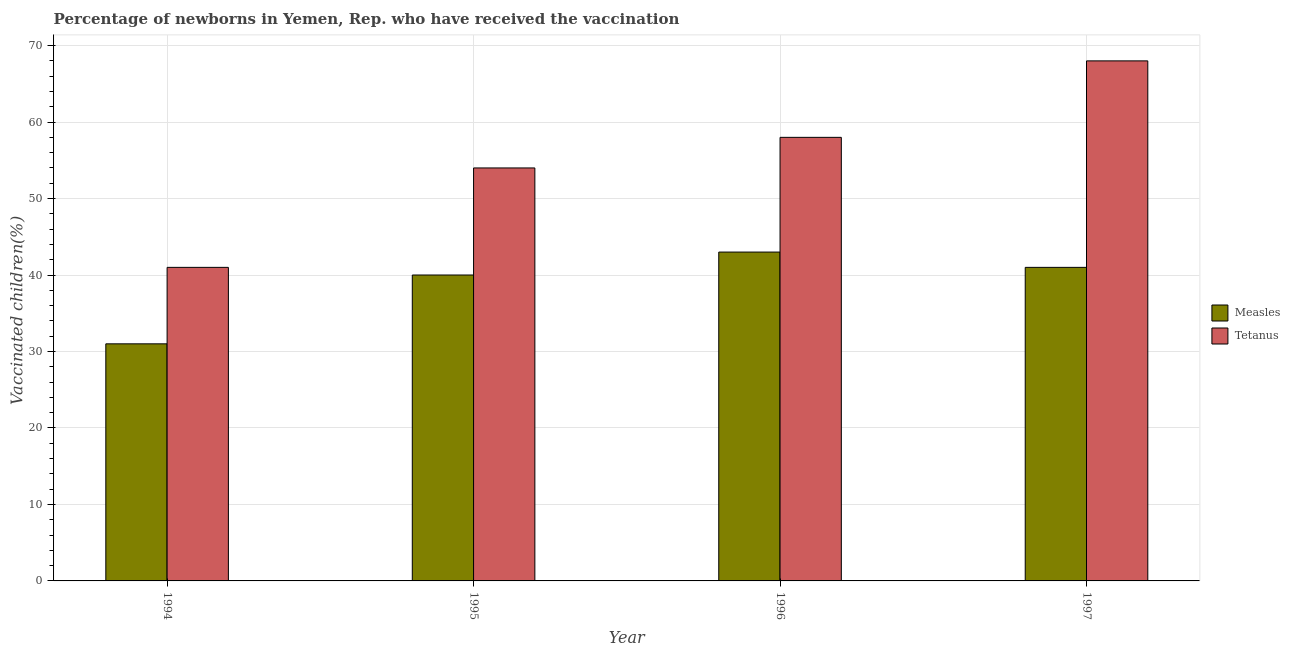How many different coloured bars are there?
Provide a succinct answer. 2. How many groups of bars are there?
Offer a very short reply. 4. Are the number of bars per tick equal to the number of legend labels?
Give a very brief answer. Yes. Are the number of bars on each tick of the X-axis equal?
Make the answer very short. Yes. What is the percentage of newborns who received vaccination for tetanus in 1995?
Your answer should be very brief. 54. Across all years, what is the maximum percentage of newborns who received vaccination for measles?
Provide a short and direct response. 43. Across all years, what is the minimum percentage of newborns who received vaccination for measles?
Your answer should be very brief. 31. What is the total percentage of newborns who received vaccination for measles in the graph?
Offer a very short reply. 155. What is the difference between the percentage of newborns who received vaccination for measles in 1994 and that in 1997?
Keep it short and to the point. -10. What is the difference between the percentage of newborns who received vaccination for measles in 1997 and the percentage of newborns who received vaccination for tetanus in 1996?
Ensure brevity in your answer.  -2. What is the average percentage of newborns who received vaccination for tetanus per year?
Your answer should be very brief. 55.25. In the year 1995, what is the difference between the percentage of newborns who received vaccination for tetanus and percentage of newborns who received vaccination for measles?
Your answer should be very brief. 0. In how many years, is the percentage of newborns who received vaccination for tetanus greater than 52 %?
Provide a succinct answer. 3. What is the ratio of the percentage of newborns who received vaccination for tetanus in 1995 to that in 1996?
Provide a short and direct response. 0.93. Is the percentage of newborns who received vaccination for tetanus in 1995 less than that in 1997?
Make the answer very short. Yes. What is the difference between the highest and the lowest percentage of newborns who received vaccination for tetanus?
Provide a short and direct response. 27. In how many years, is the percentage of newborns who received vaccination for measles greater than the average percentage of newborns who received vaccination for measles taken over all years?
Provide a succinct answer. 3. Is the sum of the percentage of newborns who received vaccination for tetanus in 1994 and 1995 greater than the maximum percentage of newborns who received vaccination for measles across all years?
Give a very brief answer. Yes. What does the 1st bar from the left in 1994 represents?
Your response must be concise. Measles. What does the 1st bar from the right in 1996 represents?
Your answer should be compact. Tetanus. Are all the bars in the graph horizontal?
Make the answer very short. No. How many years are there in the graph?
Provide a succinct answer. 4. Are the values on the major ticks of Y-axis written in scientific E-notation?
Make the answer very short. No. Does the graph contain grids?
Offer a terse response. Yes. How are the legend labels stacked?
Offer a terse response. Vertical. What is the title of the graph?
Your response must be concise. Percentage of newborns in Yemen, Rep. who have received the vaccination. What is the label or title of the Y-axis?
Keep it short and to the point. Vaccinated children(%)
. What is the Vaccinated children(%)
 in Measles in 1994?
Provide a short and direct response. 31. What is the Vaccinated children(%)
 of Tetanus in 1996?
Provide a short and direct response. 58. What is the Vaccinated children(%)
 of Tetanus in 1997?
Keep it short and to the point. 68. What is the total Vaccinated children(%)
 in Measles in the graph?
Provide a short and direct response. 155. What is the total Vaccinated children(%)
 in Tetanus in the graph?
Provide a succinct answer. 221. What is the difference between the Vaccinated children(%)
 in Tetanus in 1994 and that in 1995?
Give a very brief answer. -13. What is the difference between the Vaccinated children(%)
 in Measles in 1994 and that in 1996?
Provide a succinct answer. -12. What is the difference between the Vaccinated children(%)
 of Tetanus in 1994 and that in 1997?
Provide a succinct answer. -27. What is the difference between the Vaccinated children(%)
 of Tetanus in 1995 and that in 1996?
Provide a succinct answer. -4. What is the difference between the Vaccinated children(%)
 of Measles in 1995 and that in 1997?
Ensure brevity in your answer.  -1. What is the difference between the Vaccinated children(%)
 of Tetanus in 1996 and that in 1997?
Provide a short and direct response. -10. What is the difference between the Vaccinated children(%)
 in Measles in 1994 and the Vaccinated children(%)
 in Tetanus in 1995?
Keep it short and to the point. -23. What is the difference between the Vaccinated children(%)
 of Measles in 1994 and the Vaccinated children(%)
 of Tetanus in 1996?
Provide a succinct answer. -27. What is the difference between the Vaccinated children(%)
 in Measles in 1994 and the Vaccinated children(%)
 in Tetanus in 1997?
Offer a very short reply. -37. What is the difference between the Vaccinated children(%)
 in Measles in 1995 and the Vaccinated children(%)
 in Tetanus in 1996?
Make the answer very short. -18. What is the average Vaccinated children(%)
 of Measles per year?
Your answer should be compact. 38.75. What is the average Vaccinated children(%)
 in Tetanus per year?
Your response must be concise. 55.25. In the year 1994, what is the difference between the Vaccinated children(%)
 of Measles and Vaccinated children(%)
 of Tetanus?
Make the answer very short. -10. In the year 1997, what is the difference between the Vaccinated children(%)
 in Measles and Vaccinated children(%)
 in Tetanus?
Your response must be concise. -27. What is the ratio of the Vaccinated children(%)
 of Measles in 1994 to that in 1995?
Your answer should be very brief. 0.78. What is the ratio of the Vaccinated children(%)
 in Tetanus in 1994 to that in 1995?
Offer a very short reply. 0.76. What is the ratio of the Vaccinated children(%)
 of Measles in 1994 to that in 1996?
Make the answer very short. 0.72. What is the ratio of the Vaccinated children(%)
 in Tetanus in 1994 to that in 1996?
Give a very brief answer. 0.71. What is the ratio of the Vaccinated children(%)
 in Measles in 1994 to that in 1997?
Give a very brief answer. 0.76. What is the ratio of the Vaccinated children(%)
 of Tetanus in 1994 to that in 1997?
Offer a very short reply. 0.6. What is the ratio of the Vaccinated children(%)
 of Measles in 1995 to that in 1996?
Make the answer very short. 0.93. What is the ratio of the Vaccinated children(%)
 of Tetanus in 1995 to that in 1996?
Offer a terse response. 0.93. What is the ratio of the Vaccinated children(%)
 of Measles in 1995 to that in 1997?
Offer a terse response. 0.98. What is the ratio of the Vaccinated children(%)
 in Tetanus in 1995 to that in 1997?
Offer a terse response. 0.79. What is the ratio of the Vaccinated children(%)
 of Measles in 1996 to that in 1997?
Keep it short and to the point. 1.05. What is the ratio of the Vaccinated children(%)
 in Tetanus in 1996 to that in 1997?
Ensure brevity in your answer.  0.85. What is the difference between the highest and the lowest Vaccinated children(%)
 in Measles?
Make the answer very short. 12. What is the difference between the highest and the lowest Vaccinated children(%)
 in Tetanus?
Provide a short and direct response. 27. 